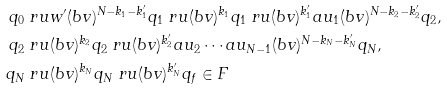Convert formula to latex. <formula><loc_0><loc_0><loc_500><loc_500>q _ { 0 } & \ r u { w ^ { \prime } ( b v ) ^ { N - k _ { 1 } - k ^ { \prime } _ { 1 } } } q _ { 1 } \ r u { ( b v ) ^ { k _ { 1 } } } q _ { 1 } \ r u { ( b v ) ^ { k ^ { \prime } _ { 1 } } a u _ { 1 } ( b v ) ^ { N - k _ { 2 } - k ^ { \prime } _ { 2 } } } q _ { 2 } , \\ q _ { 2 } & \ r u { ( b v ) ^ { k _ { 2 } } } q _ { 2 } \ r u { ( b v ) ^ { k ^ { \prime } _ { 2 } } a u _ { 2 } \cdots a u _ { N - 1 } ( b v ) ^ { N - k _ { N } - k ^ { \prime } _ { N } } } q _ { N } , \\ q _ { N } & \ r u { ( b v ) ^ { k _ { N } } } q _ { N } \ r u { ( b v ) ^ { k ^ { \prime } _ { N } } } q _ { f } \in F</formula> 